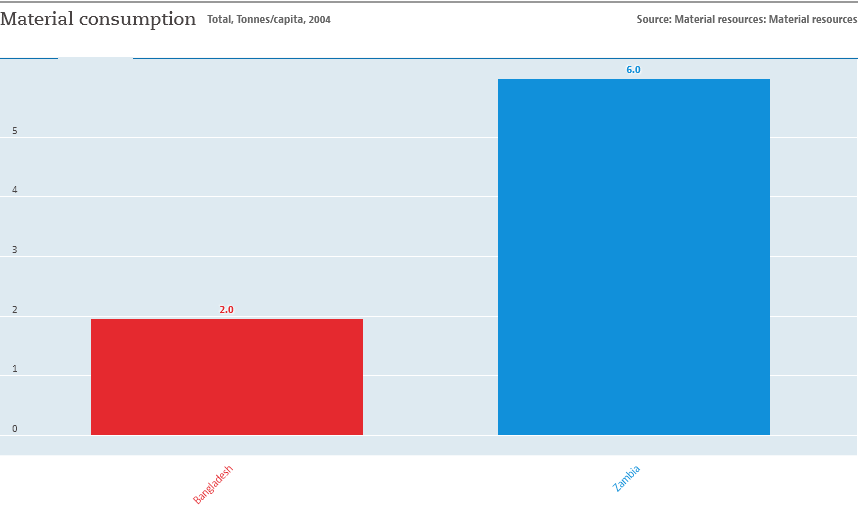Point out several critical features in this image. The average value of two bars is 4. Zambia was represented by a blue bar in a country comparison chart. 